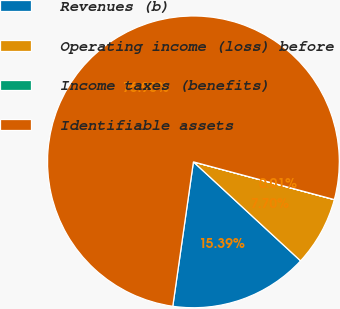Convert chart. <chart><loc_0><loc_0><loc_500><loc_500><pie_chart><fcel>Revenues (b)<fcel>Operating income (loss) before<fcel>Income taxes (benefits)<fcel>Identifiable assets<nl><fcel>15.39%<fcel>7.7%<fcel>0.01%<fcel>76.91%<nl></chart> 